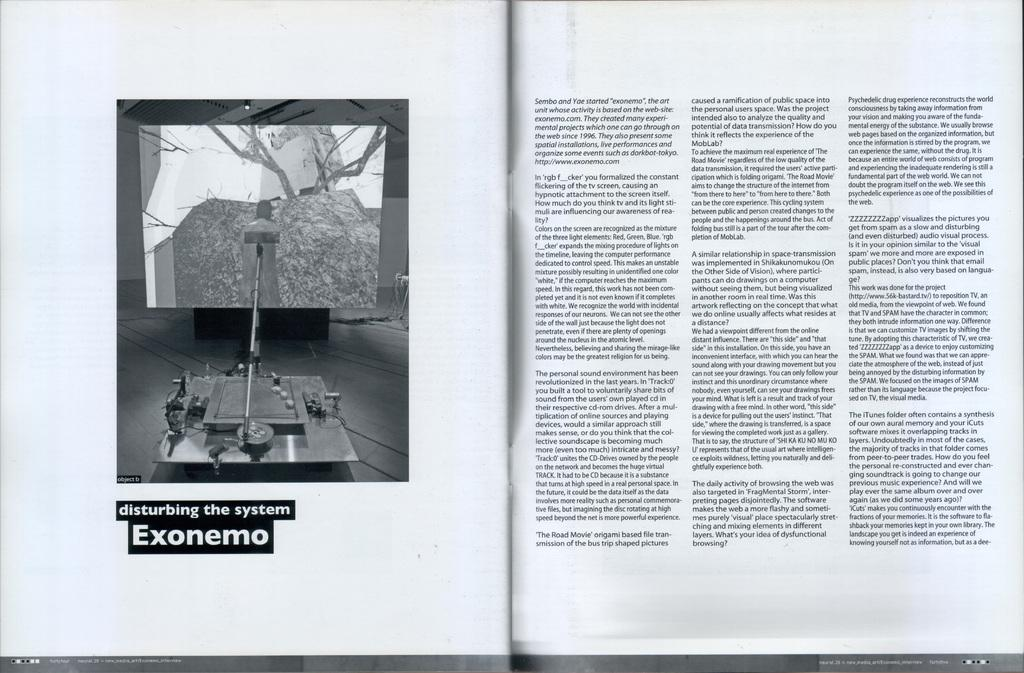<image>
Give a short and clear explanation of the subsequent image. the word exonemo that is in a little book 